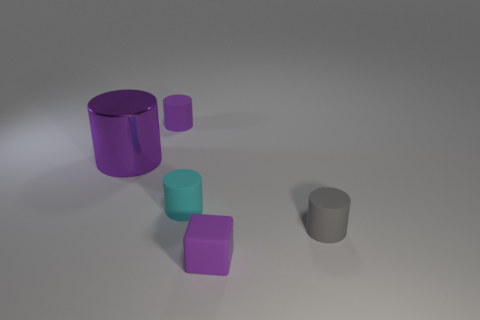There is a small purple object that is the same shape as the gray rubber thing; what is it made of?
Provide a succinct answer. Rubber. What size is the purple matte thing that is in front of the small matte object that is to the right of the purple object in front of the tiny gray rubber object?
Give a very brief answer. Small. Is the size of the cyan cylinder the same as the block?
Keep it short and to the point. Yes. What is the material of the tiny cylinder on the left side of the cyan cylinder on the left side of the tiny purple block?
Keep it short and to the point. Rubber. Do the tiny matte thing behind the big purple shiny thing and the purple rubber thing that is in front of the small gray rubber cylinder have the same shape?
Provide a succinct answer. No. Is the number of tiny cyan matte objects behind the gray cylinder the same as the number of tiny cyan rubber objects?
Your response must be concise. Yes. Are there any tiny cyan rubber things in front of the small purple matte object that is behind the large metallic cylinder?
Keep it short and to the point. Yes. Is the small purple object behind the big cylinder made of the same material as the large cylinder?
Offer a terse response. No. Is the number of large objects behind the large metal object the same as the number of tiny gray rubber things that are in front of the tiny gray matte thing?
Ensure brevity in your answer.  Yes. There is a purple rubber thing in front of the tiny purple object behind the cyan cylinder; what size is it?
Offer a terse response. Small. 